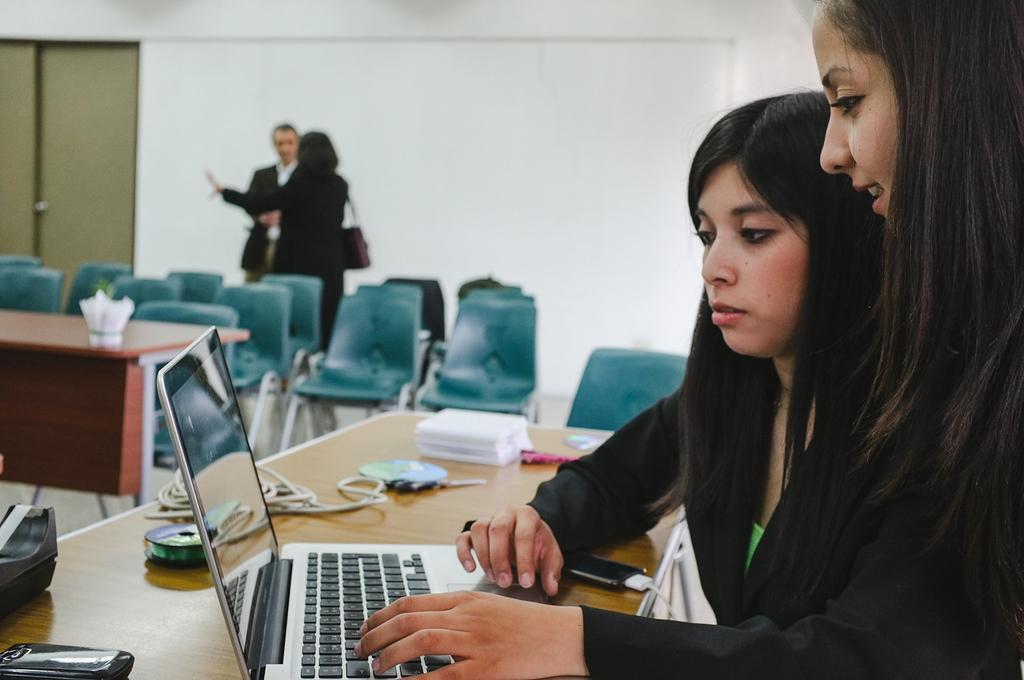How would you summarize this image in a sentence or two? Two women are looking into laptop sitting at a table. There some items on the table. There are some chairs and a table in the background. A man and a woman are talking at a distance. 